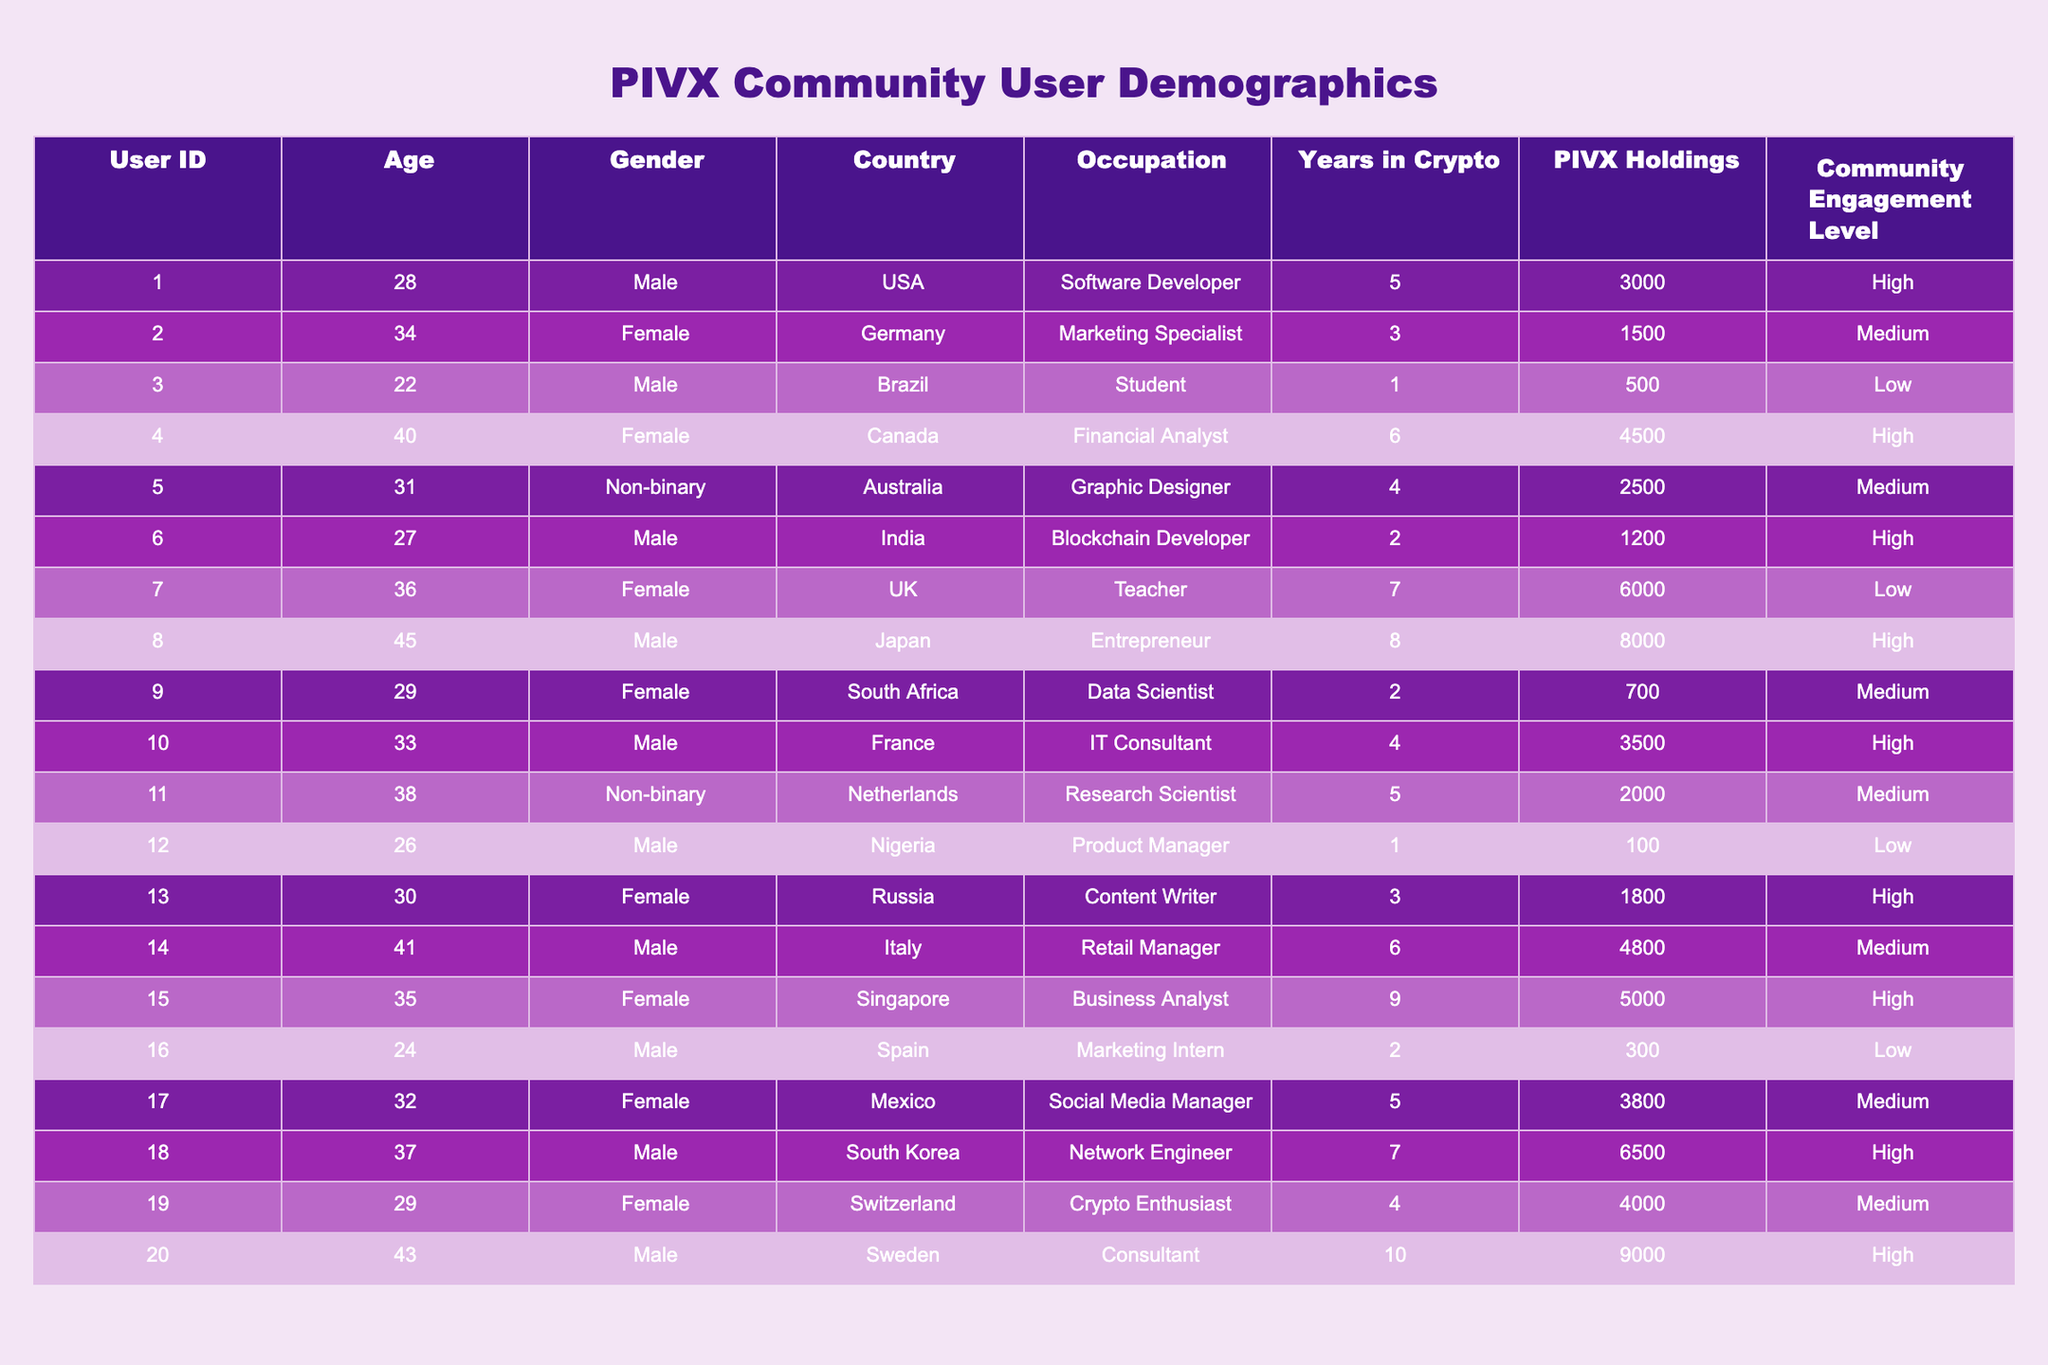What is the age of the youngest PIVX community member? Looking at the "Age" column, the youngest member is User ID 3, who is 22 years old.
Answer: 22 How many users have High community engagement? Counting the "Community Engagement Level" column, there are 8 users with a High engagement level.
Answer: 8 What is the average amount of PIVX holdings among community members? To find the average, sum PIVX holdings (3000 + 1500 + 500 + 4500 + 2500 + 1200 + 6000 + 8000 + 700 + 3500 + 2000 + 100 + 1800 + 4800 + 5000 + 300 + 3800 + 6500 + 4000 + 9000) = 42600. There are 20 members, so the average is 42600/20 = 2130.
Answer: 2130 Which country has the highest number of community members? Counting the entries in the "Country" column, the USA has 1 member, Germany has 1, Brazil has 1, Canada has 1, Australia has 1, India has 1, UK has 1, Japan has 1, South Africa has 1, France has 1, Netherlands has 1, Nigeria has 1, Russia has 1, Italy has 1, Singapore has 1, Spain has 1, Mexico has 1, South Korea has 1, Switzerland has 1, and Sweden has 1. Each country has only one member, so no country has more than another.
Answer: None Is there anyone in the community with more than 7000 PIVX holdings? Reviewing the "PIVX Holdings" column, Users 8, 20 have more than 7000 PIVX holdings (8000 and 9000 respectively), so the answer is yes.
Answer: Yes What is the median age of PIVX community members? To find the median, we list ages: 22, 24, 26, 27, 28, 29, 30, 31, 32, 33, 34, 35, 36, 37, 38, 40, 41, 43, 45, 48. Since there are 20 members, the median is the average of the 10th and 11th values: (33 + 34)/2 = 33.5.
Answer: 33.5 How many members have been in the crypto space for more than 5 years? Users with more than 5 years in crypto are those with entries of 6 and 9 years: User IDs 4, 8, 15, and 20, making a total of 4 members.
Answer: 4 What is the difference in PIVX holdings between the member with the highest and lowest holdings? The member with the highest holdings, User 20, has 9000, while the lowest, User 12, has 100. The difference is 9000 - 100 = 8900.
Answer: 8900 Are there any Non-binary community members? Checking the "Gender" column, there are 2 Non-binary members (User ID 5 and 11). Therefore, the answer is yes.
Answer: Yes How many different occupations are represented by the PIVX community members? Listing the unique occupations: Software Developer, Marketing Specialist, Student, Financial Analyst, Graphic Designer, Blockchain Developer, Teacher, Entrepreneur, Data Scientist, IT Consultant, Research Scientist, Product Manager, Content Writer, Retail Manager, Business Analyst, Marketing Intern, Social Media Manager, Network Engineer, and Consultant totals to 20 different occupations.
Answer: 20 What is the average years in crypto for community members with a Low engagement level? For Low engagement users (IDs 3, 7, 12, 16), the years in crypto are 1, 1, 1, and 2. The total is 1 + 1 + 1 + 2 = 5, and the average is 5/4 = 1.25.
Answer: 1.25 